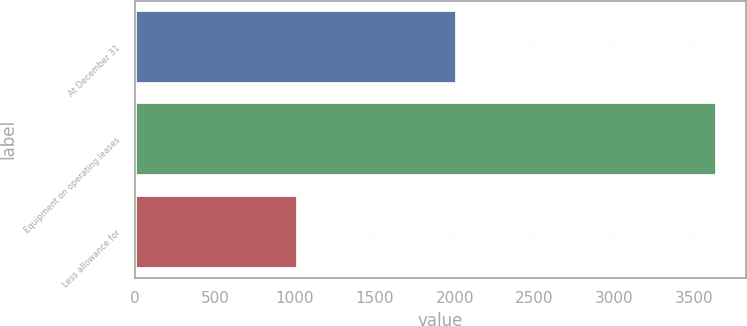Convert chart. <chart><loc_0><loc_0><loc_500><loc_500><bar_chart><fcel>At December 31<fcel>Equipment on operating leases<fcel>Less allowance for<nl><fcel>2016<fcel>3640.6<fcel>1016.7<nl></chart> 